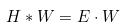Convert formula to latex. <formula><loc_0><loc_0><loc_500><loc_500>H * W = E \cdot W</formula> 